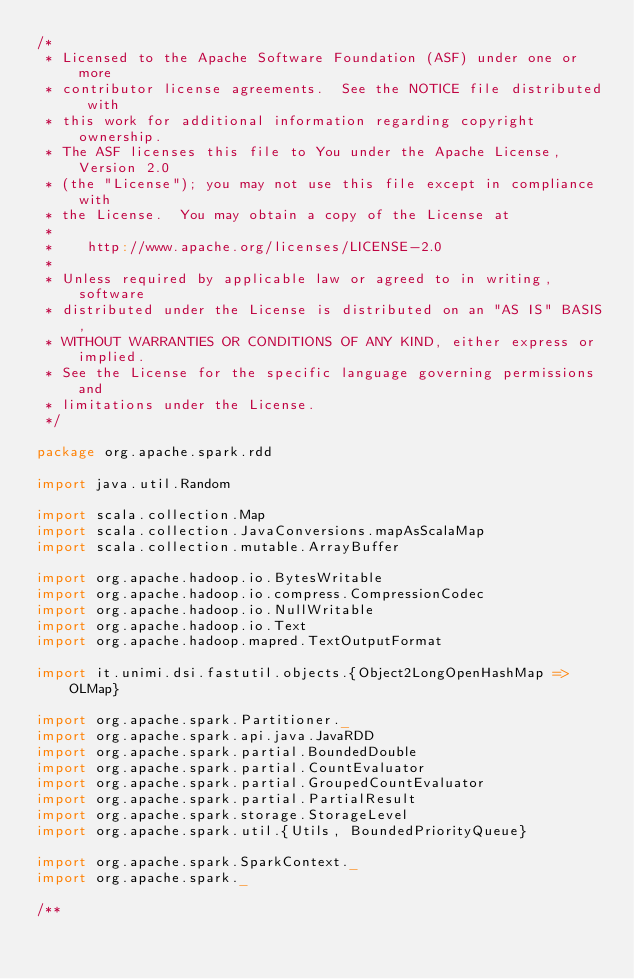Convert code to text. <code><loc_0><loc_0><loc_500><loc_500><_Scala_>/*
 * Licensed to the Apache Software Foundation (ASF) under one or more
 * contributor license agreements.  See the NOTICE file distributed with
 * this work for additional information regarding copyright ownership.
 * The ASF licenses this file to You under the Apache License, Version 2.0
 * (the "License"); you may not use this file except in compliance with
 * the License.  You may obtain a copy of the License at
 *
 *    http://www.apache.org/licenses/LICENSE-2.0
 *
 * Unless required by applicable law or agreed to in writing, software
 * distributed under the License is distributed on an "AS IS" BASIS,
 * WITHOUT WARRANTIES OR CONDITIONS OF ANY KIND, either express or implied.
 * See the License for the specific language governing permissions and
 * limitations under the License.
 */

package org.apache.spark.rdd

import java.util.Random

import scala.collection.Map
import scala.collection.JavaConversions.mapAsScalaMap
import scala.collection.mutable.ArrayBuffer

import org.apache.hadoop.io.BytesWritable
import org.apache.hadoop.io.compress.CompressionCodec
import org.apache.hadoop.io.NullWritable
import org.apache.hadoop.io.Text
import org.apache.hadoop.mapred.TextOutputFormat

import it.unimi.dsi.fastutil.objects.{Object2LongOpenHashMap => OLMap}

import org.apache.spark.Partitioner._
import org.apache.spark.api.java.JavaRDD
import org.apache.spark.partial.BoundedDouble
import org.apache.spark.partial.CountEvaluator
import org.apache.spark.partial.GroupedCountEvaluator
import org.apache.spark.partial.PartialResult
import org.apache.spark.storage.StorageLevel
import org.apache.spark.util.{Utils, BoundedPriorityQueue}

import org.apache.spark.SparkContext._
import org.apache.spark._

/**</code> 